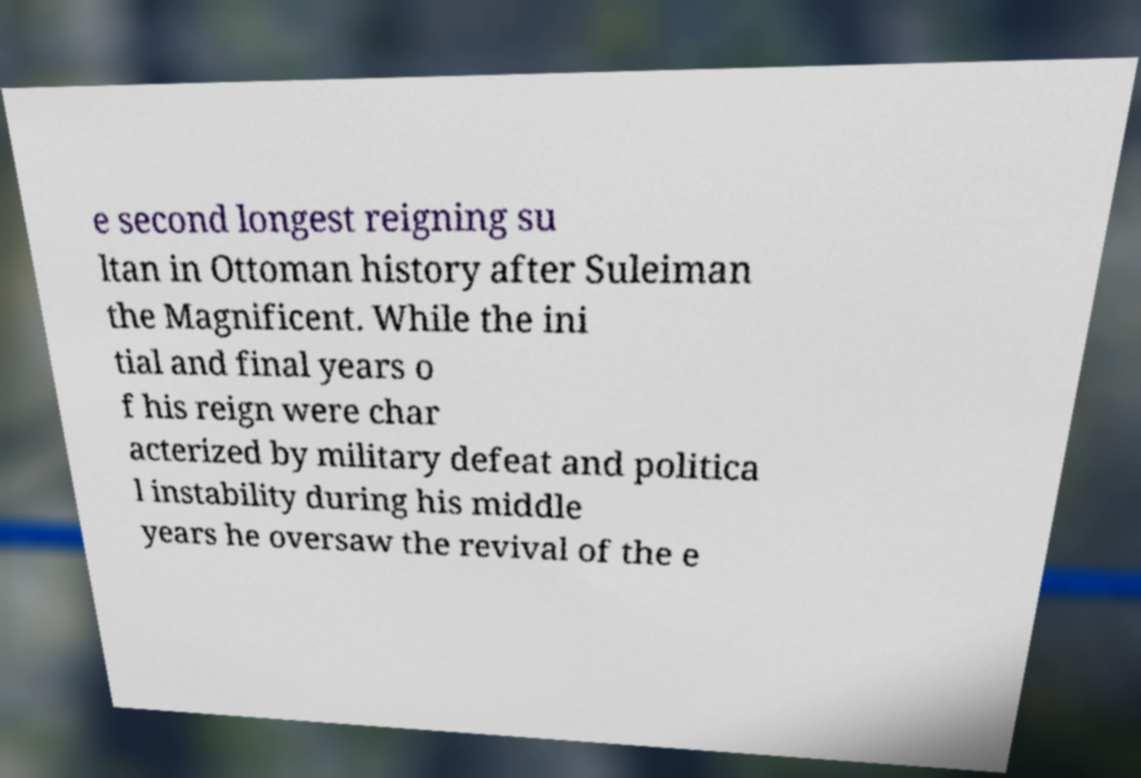Please identify and transcribe the text found in this image. e second longest reigning su ltan in Ottoman history after Suleiman the Magnificent. While the ini tial and final years o f his reign were char acterized by military defeat and politica l instability during his middle years he oversaw the revival of the e 